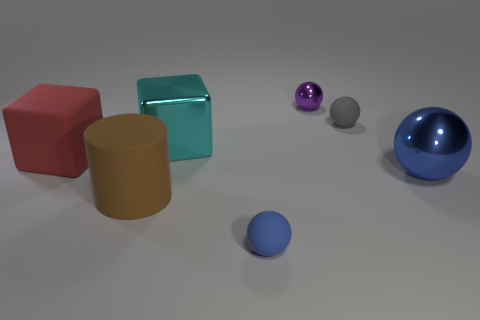Is the number of gray things that are on the left side of the red object greater than the number of objects behind the large blue sphere? No, the number of gray things on the left side of the red object is not greater; in fact, there is only one gray sphere visible. Similarly, behind the large blue sphere, there appears to be only one object—a small blue sphere. 